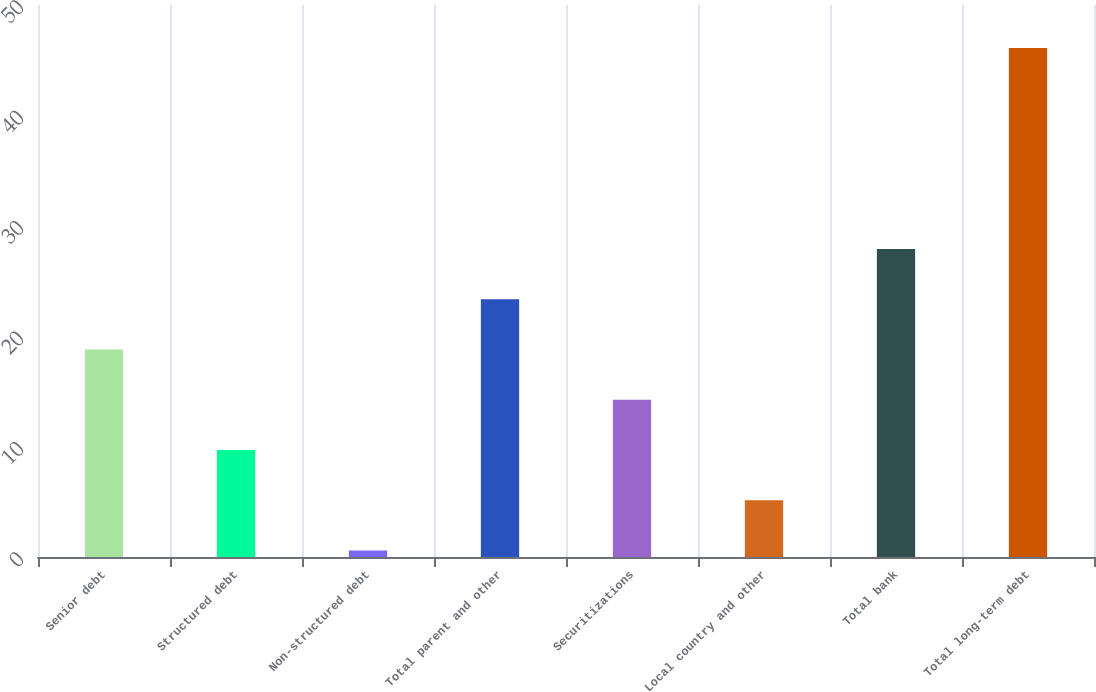Convert chart. <chart><loc_0><loc_0><loc_500><loc_500><bar_chart><fcel>Senior debt<fcel>Structured debt<fcel>Non-structured debt<fcel>Total parent and other<fcel>Securitizations<fcel>Local country and other<fcel>Total bank<fcel>Total long-term debt<nl><fcel>18.8<fcel>9.7<fcel>0.6<fcel>23.35<fcel>14.25<fcel>5.15<fcel>27.9<fcel>46.1<nl></chart> 